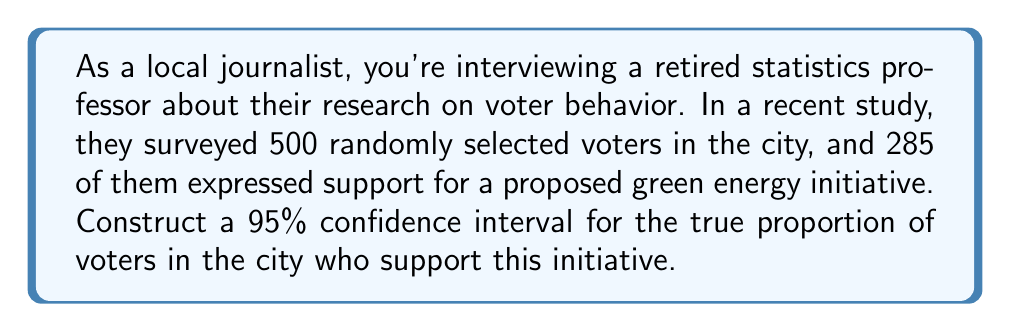Solve this math problem. To construct a 95% confidence interval for a population proportion, we'll follow these steps:

1) First, let's identify our variables:
   $n$ = sample size = 500
   $\hat{p}$ = sample proportion = 285/500 = 0.57
   Confidence level = 95%, so $z^*$ = 1.96

2) The formula for the confidence interval is:

   $$\hat{p} \pm z^* \sqrt{\frac{\hat{p}(1-\hat{p})}{n}}$$

3) Calculate $\hat{p}(1-\hat{p})$:
   $0.57(1-0.57) = 0.57(0.43) = 0.2451$

4) Divide by $n$ and take the square root:
   $$\sqrt{\frac{0.2451}{500}} = \sqrt{0.0004902} = 0.02214$$

5) Multiply by $z^*$:
   $1.96 * 0.02214 = 0.04339$

6) Calculate the lower and upper bounds:
   Lower bound: $0.57 - 0.04339 = 0.52661$
   Upper bound: $0.57 + 0.04339 = 0.61339$

7) Therefore, we can say we are 95% confident that the true proportion of voters who support the green energy initiative is between 0.52661 and 0.61339, or between 52.66% and 61.34% when expressed as percentages.
Answer: (0.52661, 0.61339) 